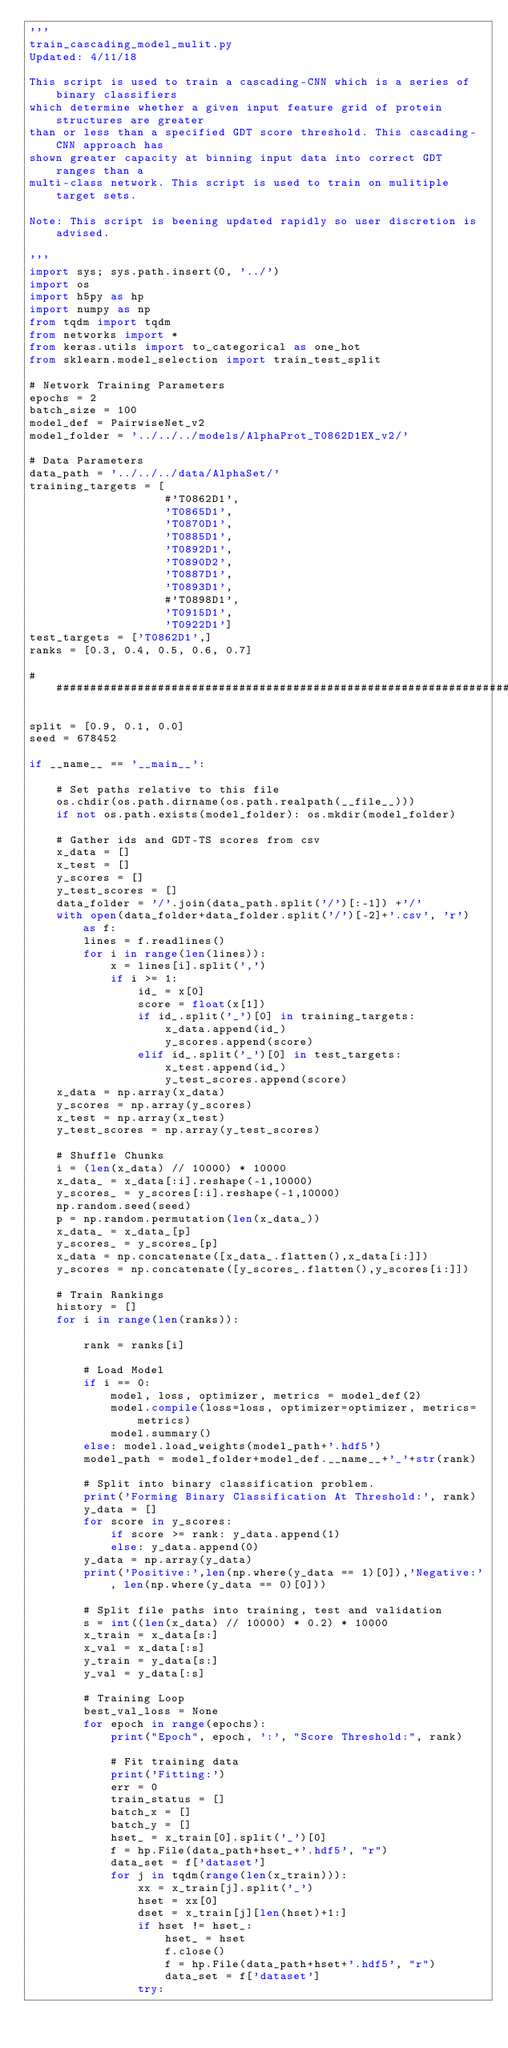Convert code to text. <code><loc_0><loc_0><loc_500><loc_500><_Python_>'''
train_cascading_model_mulit.py
Updated: 4/11/18

This script is used to train a cascading-CNN which is a series of binary classifiers
which determine whether a given input feature grid of protein structures are greater
than or less than a specified GDT score threshold. This cascading-CNN approach has
shown greater capacity at binning input data into correct GDT ranges than a
multi-class network. This script is used to train on mulitiple target sets.

Note: This script is beening updated rapidly so user discretion is advised.

'''
import sys; sys.path.insert(0, '../')
import os
import h5py as hp
import numpy as np
from tqdm import tqdm
from networks import *
from keras.utils import to_categorical as one_hot
from sklearn.model_selection import train_test_split

# Network Training Parameters
epochs = 2
batch_size = 100
model_def = PairwiseNet_v2
model_folder = '../../../models/AlphaProt_T0862D1EX_v2/'

# Data Parameters
data_path = '../../../data/AlphaSet/'
training_targets = [
                    #'T0862D1',
                    'T0865D1',
                    'T0870D1',
                    'T0885D1',
                    'T0892D1',
                    'T0890D2',
                    'T0887D1',
                    'T0893D1',
                    #'T0898D1',
                    'T0915D1',
                    'T0922D1']
test_targets = ['T0862D1',]
ranks = [0.3, 0.4, 0.5, 0.6, 0.7]

################################################################################

split = [0.9, 0.1, 0.0]
seed = 678452

if __name__ == '__main__':

    # Set paths relative to this file
    os.chdir(os.path.dirname(os.path.realpath(__file__)))
    if not os.path.exists(model_folder): os.mkdir(model_folder)

    # Gather ids and GDT-TS scores from csv
    x_data = []
    x_test = []
    y_scores = []
    y_test_scores = []
    data_folder = '/'.join(data_path.split('/')[:-1]) +'/'
    with open(data_folder+data_folder.split('/')[-2]+'.csv', 'r') as f:
        lines = f.readlines()
        for i in range(len(lines)):
            x = lines[i].split(',')
            if i >= 1:
                id_ = x[0]
                score = float(x[1])
                if id_.split('_')[0] in training_targets:
                    x_data.append(id_)
                    y_scores.append(score)
                elif id_.split('_')[0] in test_targets:
                    x_test.append(id_)
                    y_test_scores.append(score)
    x_data = np.array(x_data)
    y_scores = np.array(y_scores)
    x_test = np.array(x_test)
    y_test_scores = np.array(y_test_scores)

    # Shuffle Chunks
    i = (len(x_data) // 10000) * 10000
    x_data_ = x_data[:i].reshape(-1,10000)
    y_scores_ = y_scores[:i].reshape(-1,10000)
    np.random.seed(seed)
    p = np.random.permutation(len(x_data_))
    x_data_ = x_data_[p]
    y_scores_ = y_scores_[p]
    x_data = np.concatenate([x_data_.flatten(),x_data[i:]])
    y_scores = np.concatenate([y_scores_.flatten(),y_scores[i:]])

    # Train Rankings
    history = []
    for i in range(len(ranks)):

        rank = ranks[i]

        # Load Model
        if i == 0:
            model, loss, optimizer, metrics = model_def(2)
            model.compile(loss=loss, optimizer=optimizer, metrics=metrics)
            model.summary()
        else: model.load_weights(model_path+'.hdf5')
        model_path = model_folder+model_def.__name__+'_'+str(rank)

        # Split into binary classification problem.
        print('Forming Binary Classification At Threshold:', rank)
        y_data = []
        for score in y_scores:
            if score >= rank: y_data.append(1)
            else: y_data.append(0)
        y_data = np.array(y_data)
        print('Positive:',len(np.where(y_data == 1)[0]),'Negative:', len(np.where(y_data == 0)[0]))

        # Split file paths into training, test and validation
        s = int((len(x_data) // 10000) * 0.2) * 10000
        x_train = x_data[s:]
        x_val = x_data[:s]
        y_train = y_data[s:]
        y_val = y_data[:s]

        # Training Loop
        best_val_loss = None
        for epoch in range(epochs):
            print("Epoch", epoch, ':', "Score Threshold:", rank)

            # Fit training data
            print('Fitting:')
            err = 0
            train_status = []
            batch_x = []
            batch_y = []
            hset_ = x_train[0].split('_')[0]
            f = hp.File(data_path+hset_+'.hdf5', "r")
            data_set = f['dataset']
            for j in tqdm(range(len(x_train))):
                xx = x_train[j].split('_')
                hset = xx[0]
                dset = x_train[j][len(hset)+1:]
                if hset != hset_:
                    hset_ = hset
                    f.close()
                    f = hp.File(data_path+hset+'.hdf5', "r")
                    data_set = f['dataset']
                try:</code> 